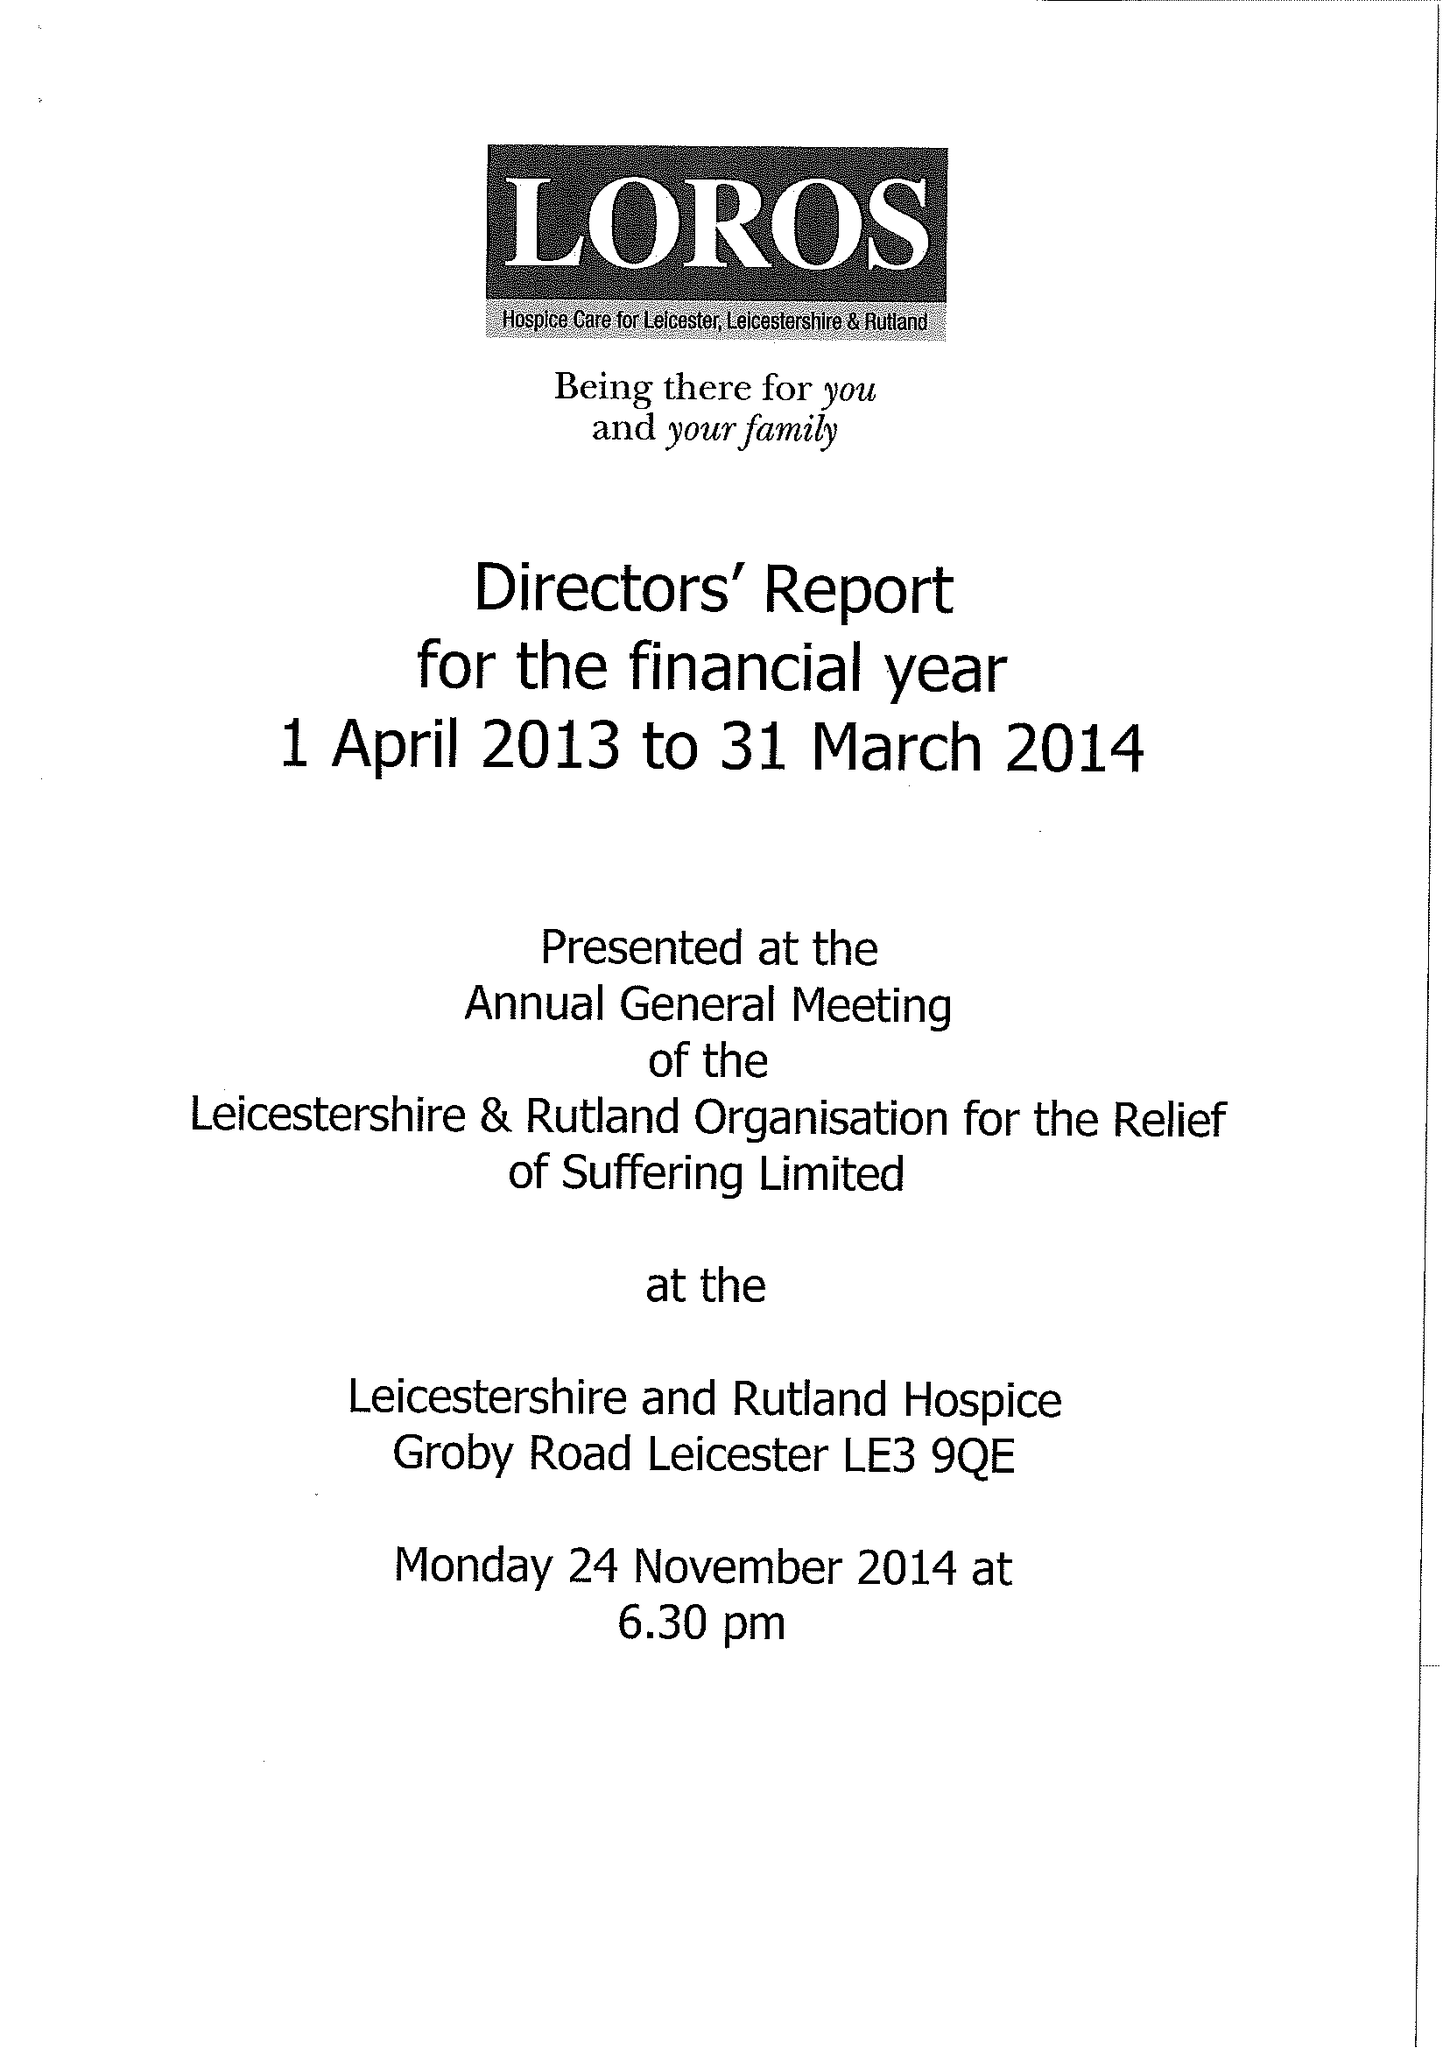What is the value for the spending_annually_in_british_pounds?
Answer the question using a single word or phrase. 11363862.00 